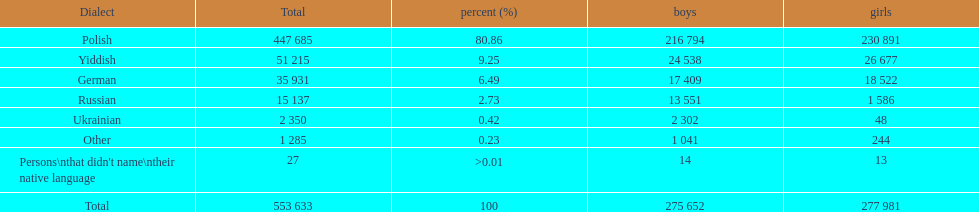How many languages have a name that is derived from a country? 4. 